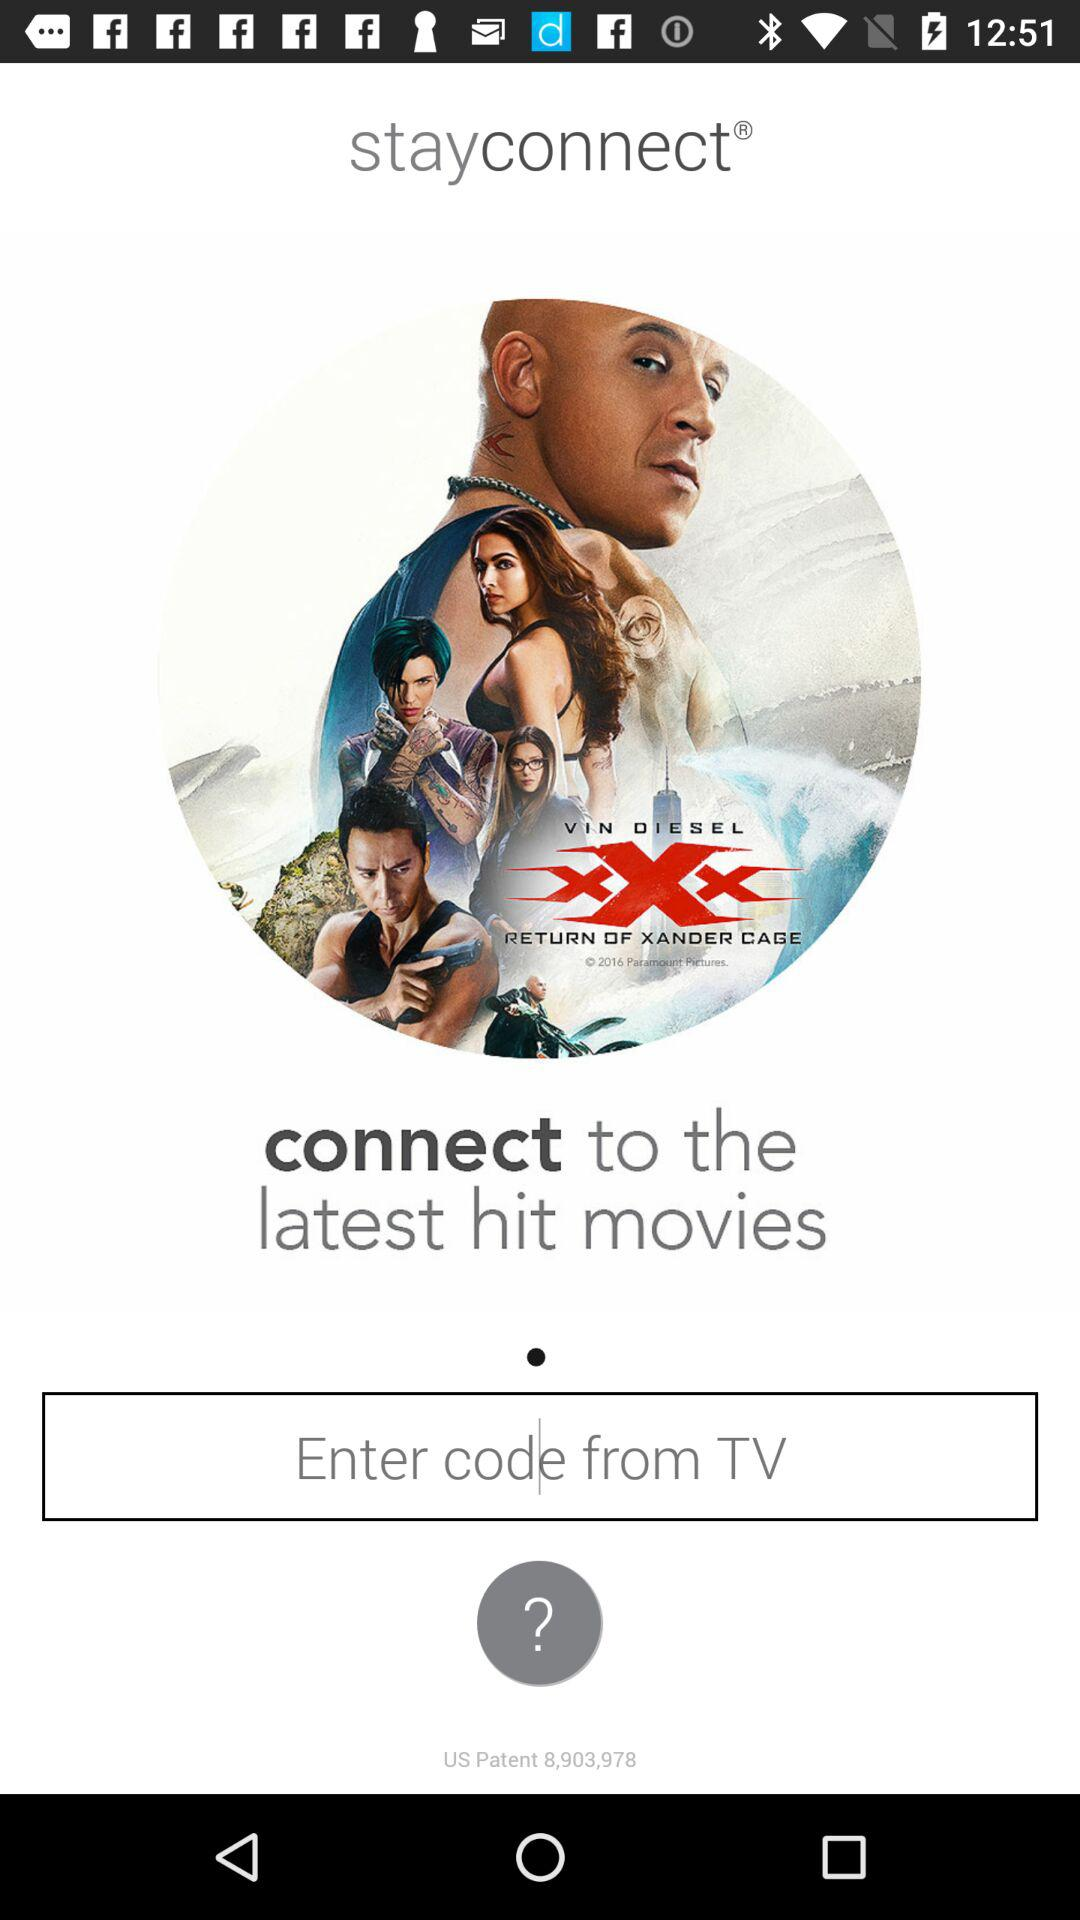What is the name of the application? The name of the application is "stayconnect". 